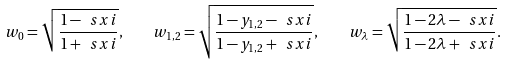Convert formula to latex. <formula><loc_0><loc_0><loc_500><loc_500>w _ { 0 } = \sqrt { \frac { 1 - \ s x i } { 1 + \ s x i } } , \quad w _ { 1 , 2 } = \sqrt { \frac { 1 - y _ { 1 , 2 } - \ s x i } { 1 - y _ { 1 , 2 } + \ s x i } } , \quad w _ { \lambda } = \sqrt { \frac { 1 - 2 \lambda - \ s x i } { 1 - 2 \lambda + \ s x i } } .</formula> 